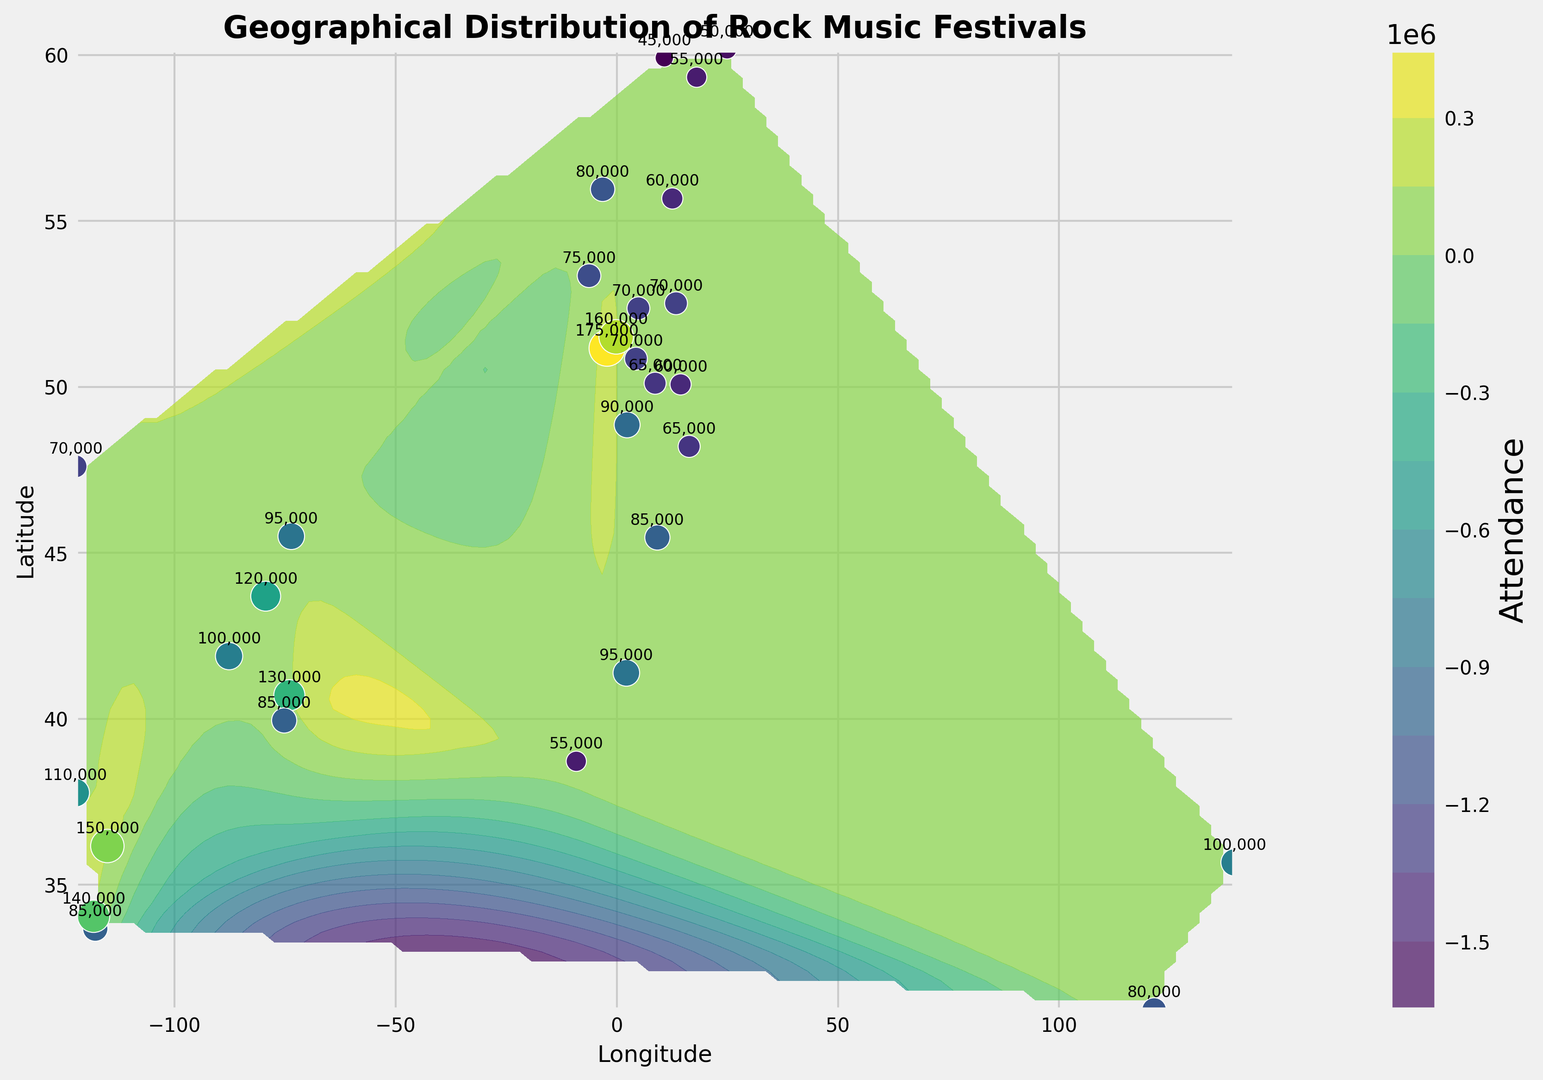What is the range of attendance values for the rock music festivals? To determine the range, find the smallest and largest attendance values. The smallest value appears to be 45,000 and the largest is 175,000. The range is the difference between these two values, 175,000 - 45,000.
Answer: 130,000 Which festival has the highest attendance? From the figure, the highest attendance annotation is 175,000. This corresponds to the festival located at approximately 51.1657°N latitude and -2.1835°E longitude.
Answer: 175,000 Are there more festivals in North America or Europe? To answer this, count the number of festival markers in each continent. Europe has more locations (with notable cities like Amsterdam, London, Paris, etc.) compared to North America (with fewer cities like Los Angeles, New York).
Answer: Europe What is the average attendance of the festivals shown? First, sum up all the attendance values: 175,000 + 120,000 + 85,000 + 100,000 + 150,000 + 70,000 + 90,000 + 80,000 + 65,000 + 55,000 + 110,000 + 130,000 + 140,000 + 160,000 + 75,000 + 95,000 + 70,000 + 85,000 + 100,000 + 80,000 + 60,000 + 70,000 + 85,000 + 95,000 + 65,000 + 55,000 + 50,000 + 45,000 + 60,000 + 70,000. The total is 2,335,000. Divide this by the number of festivals (30) to get the average.
Answer: 77,833 Which region has the lowest attendance data point, and what is that attendance figure? From visual inspection, the lowest attendance figure is 45,000, located in the Scandinavian region, specifically in Oslo, Norway.
Answer: Oslo, 45,000 How does the color intensity of the contours relate to the attendance figures? The color intensity in the contour plot represents attendance rates, with darker shades indicating higher attendance values. Areas with the highest density of darker shades correlate with higher attendances, such as the area near the dark green regions.
Answer: Darker is higher Which two festivals have the closest attendance figures, and what are these figures? By checking the annotations, festivals in Prague (60,000) and Copenhagen (60,000) have the closest attendance figures.
Answer: Prague and Copenhagen, 60,000 each Compare the attendance figures of North American festivals to those in European festivals. Which continent generally has higher attendance? European festivals are marked by generally higher attendance figures (e.g., Glastonbury, London) compared to North American festivals. Most European figures surpass 70,000, contrasting with lower averages in North America.
Answer: Europe 